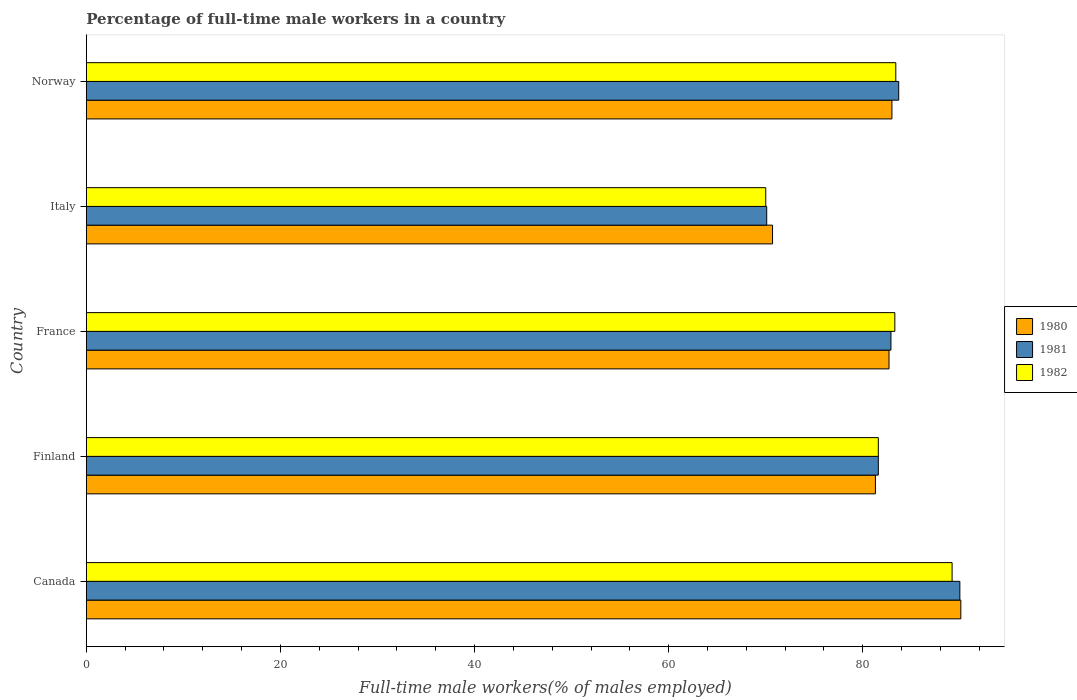How many groups of bars are there?
Make the answer very short. 5. Are the number of bars per tick equal to the number of legend labels?
Give a very brief answer. Yes. Are the number of bars on each tick of the Y-axis equal?
Offer a very short reply. Yes. How many bars are there on the 4th tick from the top?
Offer a very short reply. 3. How many bars are there on the 1st tick from the bottom?
Make the answer very short. 3. What is the label of the 4th group of bars from the top?
Make the answer very short. Finland. What is the percentage of full-time male workers in 1980 in Norway?
Provide a succinct answer. 83. Across all countries, what is the maximum percentage of full-time male workers in 1981?
Provide a short and direct response. 90. In which country was the percentage of full-time male workers in 1980 maximum?
Your response must be concise. Canada. In which country was the percentage of full-time male workers in 1980 minimum?
Provide a succinct answer. Italy. What is the total percentage of full-time male workers in 1981 in the graph?
Provide a succinct answer. 408.3. What is the difference between the percentage of full-time male workers in 1982 in Finland and the percentage of full-time male workers in 1980 in France?
Provide a succinct answer. -1.1. What is the average percentage of full-time male workers in 1982 per country?
Make the answer very short. 81.5. What is the difference between the percentage of full-time male workers in 1980 and percentage of full-time male workers in 1981 in Italy?
Ensure brevity in your answer.  0.6. In how many countries, is the percentage of full-time male workers in 1980 greater than 84 %?
Make the answer very short. 1. What is the ratio of the percentage of full-time male workers in 1982 in France to that in Norway?
Provide a succinct answer. 1. Is the percentage of full-time male workers in 1980 in Canada less than that in France?
Keep it short and to the point. No. What is the difference between the highest and the second highest percentage of full-time male workers in 1982?
Give a very brief answer. 5.8. What is the difference between the highest and the lowest percentage of full-time male workers in 1982?
Your answer should be very brief. 19.2. In how many countries, is the percentage of full-time male workers in 1981 greater than the average percentage of full-time male workers in 1981 taken over all countries?
Your answer should be compact. 3. What does the 2nd bar from the top in Finland represents?
Offer a terse response. 1981. Are all the bars in the graph horizontal?
Your answer should be very brief. Yes. What is the difference between two consecutive major ticks on the X-axis?
Your response must be concise. 20. What is the title of the graph?
Keep it short and to the point. Percentage of full-time male workers in a country. What is the label or title of the X-axis?
Ensure brevity in your answer.  Full-time male workers(% of males employed). What is the label or title of the Y-axis?
Provide a succinct answer. Country. What is the Full-time male workers(% of males employed) of 1980 in Canada?
Provide a short and direct response. 90.1. What is the Full-time male workers(% of males employed) in 1982 in Canada?
Give a very brief answer. 89.2. What is the Full-time male workers(% of males employed) in 1980 in Finland?
Your answer should be very brief. 81.3. What is the Full-time male workers(% of males employed) in 1981 in Finland?
Provide a short and direct response. 81.6. What is the Full-time male workers(% of males employed) in 1982 in Finland?
Your response must be concise. 81.6. What is the Full-time male workers(% of males employed) of 1980 in France?
Offer a very short reply. 82.7. What is the Full-time male workers(% of males employed) of 1981 in France?
Make the answer very short. 82.9. What is the Full-time male workers(% of males employed) of 1982 in France?
Make the answer very short. 83.3. What is the Full-time male workers(% of males employed) in 1980 in Italy?
Your response must be concise. 70.7. What is the Full-time male workers(% of males employed) in 1981 in Italy?
Offer a terse response. 70.1. What is the Full-time male workers(% of males employed) of 1982 in Italy?
Make the answer very short. 70. What is the Full-time male workers(% of males employed) of 1981 in Norway?
Provide a succinct answer. 83.7. What is the Full-time male workers(% of males employed) of 1982 in Norway?
Your answer should be very brief. 83.4. Across all countries, what is the maximum Full-time male workers(% of males employed) of 1980?
Provide a short and direct response. 90.1. Across all countries, what is the maximum Full-time male workers(% of males employed) of 1981?
Provide a succinct answer. 90. Across all countries, what is the maximum Full-time male workers(% of males employed) in 1982?
Keep it short and to the point. 89.2. Across all countries, what is the minimum Full-time male workers(% of males employed) of 1980?
Your response must be concise. 70.7. Across all countries, what is the minimum Full-time male workers(% of males employed) in 1981?
Your answer should be compact. 70.1. Across all countries, what is the minimum Full-time male workers(% of males employed) in 1982?
Provide a short and direct response. 70. What is the total Full-time male workers(% of males employed) in 1980 in the graph?
Keep it short and to the point. 407.8. What is the total Full-time male workers(% of males employed) of 1981 in the graph?
Your answer should be compact. 408.3. What is the total Full-time male workers(% of males employed) in 1982 in the graph?
Your answer should be very brief. 407.5. What is the difference between the Full-time male workers(% of males employed) in 1980 in Canada and that in Finland?
Your response must be concise. 8.8. What is the difference between the Full-time male workers(% of males employed) of 1982 in Canada and that in Finland?
Offer a terse response. 7.6. What is the difference between the Full-time male workers(% of males employed) in 1980 in Canada and that in France?
Make the answer very short. 7.4. What is the difference between the Full-time male workers(% of males employed) of 1982 in Canada and that in France?
Offer a terse response. 5.9. What is the difference between the Full-time male workers(% of males employed) in 1981 in Canada and that in Norway?
Keep it short and to the point. 6.3. What is the difference between the Full-time male workers(% of males employed) in 1980 in Finland and that in France?
Your answer should be compact. -1.4. What is the difference between the Full-time male workers(% of males employed) in 1982 in Finland and that in France?
Provide a short and direct response. -1.7. What is the difference between the Full-time male workers(% of males employed) of 1980 in Finland and that in Italy?
Make the answer very short. 10.6. What is the difference between the Full-time male workers(% of males employed) of 1982 in Finland and that in Italy?
Your answer should be very brief. 11.6. What is the difference between the Full-time male workers(% of males employed) in 1981 in Finland and that in Norway?
Your answer should be very brief. -2.1. What is the difference between the Full-time male workers(% of males employed) in 1981 in France and that in Norway?
Your answer should be compact. -0.8. What is the difference between the Full-time male workers(% of males employed) of 1980 in Canada and the Full-time male workers(% of males employed) of 1981 in Finland?
Make the answer very short. 8.5. What is the difference between the Full-time male workers(% of males employed) in 1980 in Canada and the Full-time male workers(% of males employed) in 1982 in Finland?
Provide a succinct answer. 8.5. What is the difference between the Full-time male workers(% of males employed) of 1981 in Canada and the Full-time male workers(% of males employed) of 1982 in France?
Ensure brevity in your answer.  6.7. What is the difference between the Full-time male workers(% of males employed) in 1980 in Canada and the Full-time male workers(% of males employed) in 1981 in Italy?
Keep it short and to the point. 20. What is the difference between the Full-time male workers(% of males employed) in 1980 in Canada and the Full-time male workers(% of males employed) in 1982 in Italy?
Offer a terse response. 20.1. What is the difference between the Full-time male workers(% of males employed) in 1981 in Canada and the Full-time male workers(% of males employed) in 1982 in Italy?
Offer a very short reply. 20. What is the difference between the Full-time male workers(% of males employed) of 1980 in Canada and the Full-time male workers(% of males employed) of 1982 in Norway?
Make the answer very short. 6.7. What is the difference between the Full-time male workers(% of males employed) in 1981 in Canada and the Full-time male workers(% of males employed) in 1982 in Norway?
Keep it short and to the point. 6.6. What is the difference between the Full-time male workers(% of males employed) of 1980 in Finland and the Full-time male workers(% of males employed) of 1982 in France?
Ensure brevity in your answer.  -2. What is the difference between the Full-time male workers(% of males employed) in 1981 in Finland and the Full-time male workers(% of males employed) in 1982 in France?
Make the answer very short. -1.7. What is the difference between the Full-time male workers(% of males employed) in 1980 in Finland and the Full-time male workers(% of males employed) in 1981 in Italy?
Your response must be concise. 11.2. What is the difference between the Full-time male workers(% of males employed) of 1980 in Finland and the Full-time male workers(% of males employed) of 1981 in Norway?
Give a very brief answer. -2.4. What is the difference between the Full-time male workers(% of males employed) in 1980 in Finland and the Full-time male workers(% of males employed) in 1982 in Norway?
Your response must be concise. -2.1. What is the difference between the Full-time male workers(% of males employed) in 1980 in France and the Full-time male workers(% of males employed) in 1981 in Italy?
Keep it short and to the point. 12.6. What is the difference between the Full-time male workers(% of males employed) in 1981 in France and the Full-time male workers(% of males employed) in 1982 in Norway?
Offer a terse response. -0.5. What is the difference between the Full-time male workers(% of males employed) in 1980 in Italy and the Full-time male workers(% of males employed) in 1981 in Norway?
Your answer should be compact. -13. What is the difference between the Full-time male workers(% of males employed) of 1981 in Italy and the Full-time male workers(% of males employed) of 1982 in Norway?
Your answer should be very brief. -13.3. What is the average Full-time male workers(% of males employed) in 1980 per country?
Your answer should be compact. 81.56. What is the average Full-time male workers(% of males employed) of 1981 per country?
Your response must be concise. 81.66. What is the average Full-time male workers(% of males employed) in 1982 per country?
Make the answer very short. 81.5. What is the difference between the Full-time male workers(% of males employed) in 1980 and Full-time male workers(% of males employed) in 1982 in Canada?
Your response must be concise. 0.9. What is the difference between the Full-time male workers(% of males employed) of 1981 and Full-time male workers(% of males employed) of 1982 in Canada?
Make the answer very short. 0.8. What is the difference between the Full-time male workers(% of males employed) in 1980 and Full-time male workers(% of males employed) in 1981 in Finland?
Your answer should be compact. -0.3. What is the difference between the Full-time male workers(% of males employed) in 1980 and Full-time male workers(% of males employed) in 1981 in France?
Your answer should be very brief. -0.2. What is the difference between the Full-time male workers(% of males employed) of 1980 and Full-time male workers(% of males employed) of 1982 in France?
Provide a succinct answer. -0.6. What is the difference between the Full-time male workers(% of males employed) of 1980 and Full-time male workers(% of males employed) of 1981 in Italy?
Your answer should be compact. 0.6. What is the difference between the Full-time male workers(% of males employed) of 1980 and Full-time male workers(% of males employed) of 1982 in Italy?
Offer a very short reply. 0.7. What is the difference between the Full-time male workers(% of males employed) of 1980 and Full-time male workers(% of males employed) of 1981 in Norway?
Your answer should be compact. -0.7. What is the difference between the Full-time male workers(% of males employed) of 1980 and Full-time male workers(% of males employed) of 1982 in Norway?
Your answer should be very brief. -0.4. What is the difference between the Full-time male workers(% of males employed) in 1981 and Full-time male workers(% of males employed) in 1982 in Norway?
Your answer should be very brief. 0.3. What is the ratio of the Full-time male workers(% of males employed) of 1980 in Canada to that in Finland?
Offer a very short reply. 1.11. What is the ratio of the Full-time male workers(% of males employed) of 1981 in Canada to that in Finland?
Provide a succinct answer. 1.1. What is the ratio of the Full-time male workers(% of males employed) of 1982 in Canada to that in Finland?
Provide a short and direct response. 1.09. What is the ratio of the Full-time male workers(% of males employed) of 1980 in Canada to that in France?
Provide a short and direct response. 1.09. What is the ratio of the Full-time male workers(% of males employed) of 1981 in Canada to that in France?
Your answer should be compact. 1.09. What is the ratio of the Full-time male workers(% of males employed) in 1982 in Canada to that in France?
Your answer should be very brief. 1.07. What is the ratio of the Full-time male workers(% of males employed) in 1980 in Canada to that in Italy?
Give a very brief answer. 1.27. What is the ratio of the Full-time male workers(% of males employed) in 1981 in Canada to that in Italy?
Offer a very short reply. 1.28. What is the ratio of the Full-time male workers(% of males employed) in 1982 in Canada to that in Italy?
Offer a very short reply. 1.27. What is the ratio of the Full-time male workers(% of males employed) in 1980 in Canada to that in Norway?
Your response must be concise. 1.09. What is the ratio of the Full-time male workers(% of males employed) of 1981 in Canada to that in Norway?
Your response must be concise. 1.08. What is the ratio of the Full-time male workers(% of males employed) in 1982 in Canada to that in Norway?
Make the answer very short. 1.07. What is the ratio of the Full-time male workers(% of males employed) of 1980 in Finland to that in France?
Give a very brief answer. 0.98. What is the ratio of the Full-time male workers(% of males employed) of 1981 in Finland to that in France?
Your answer should be compact. 0.98. What is the ratio of the Full-time male workers(% of males employed) of 1982 in Finland to that in France?
Provide a short and direct response. 0.98. What is the ratio of the Full-time male workers(% of males employed) of 1980 in Finland to that in Italy?
Offer a terse response. 1.15. What is the ratio of the Full-time male workers(% of males employed) of 1981 in Finland to that in Italy?
Give a very brief answer. 1.16. What is the ratio of the Full-time male workers(% of males employed) in 1982 in Finland to that in Italy?
Offer a terse response. 1.17. What is the ratio of the Full-time male workers(% of males employed) of 1980 in Finland to that in Norway?
Your answer should be compact. 0.98. What is the ratio of the Full-time male workers(% of males employed) in 1981 in Finland to that in Norway?
Keep it short and to the point. 0.97. What is the ratio of the Full-time male workers(% of males employed) of 1982 in Finland to that in Norway?
Provide a succinct answer. 0.98. What is the ratio of the Full-time male workers(% of males employed) in 1980 in France to that in Italy?
Keep it short and to the point. 1.17. What is the ratio of the Full-time male workers(% of males employed) in 1981 in France to that in Italy?
Your response must be concise. 1.18. What is the ratio of the Full-time male workers(% of males employed) of 1982 in France to that in Italy?
Your response must be concise. 1.19. What is the ratio of the Full-time male workers(% of males employed) of 1981 in France to that in Norway?
Provide a short and direct response. 0.99. What is the ratio of the Full-time male workers(% of males employed) in 1980 in Italy to that in Norway?
Offer a terse response. 0.85. What is the ratio of the Full-time male workers(% of males employed) in 1981 in Italy to that in Norway?
Provide a short and direct response. 0.84. What is the ratio of the Full-time male workers(% of males employed) in 1982 in Italy to that in Norway?
Ensure brevity in your answer.  0.84. What is the difference between the highest and the second highest Full-time male workers(% of males employed) in 1980?
Offer a very short reply. 7.1. What is the difference between the highest and the second highest Full-time male workers(% of males employed) of 1982?
Keep it short and to the point. 5.8. What is the difference between the highest and the lowest Full-time male workers(% of males employed) of 1980?
Your answer should be compact. 19.4. 